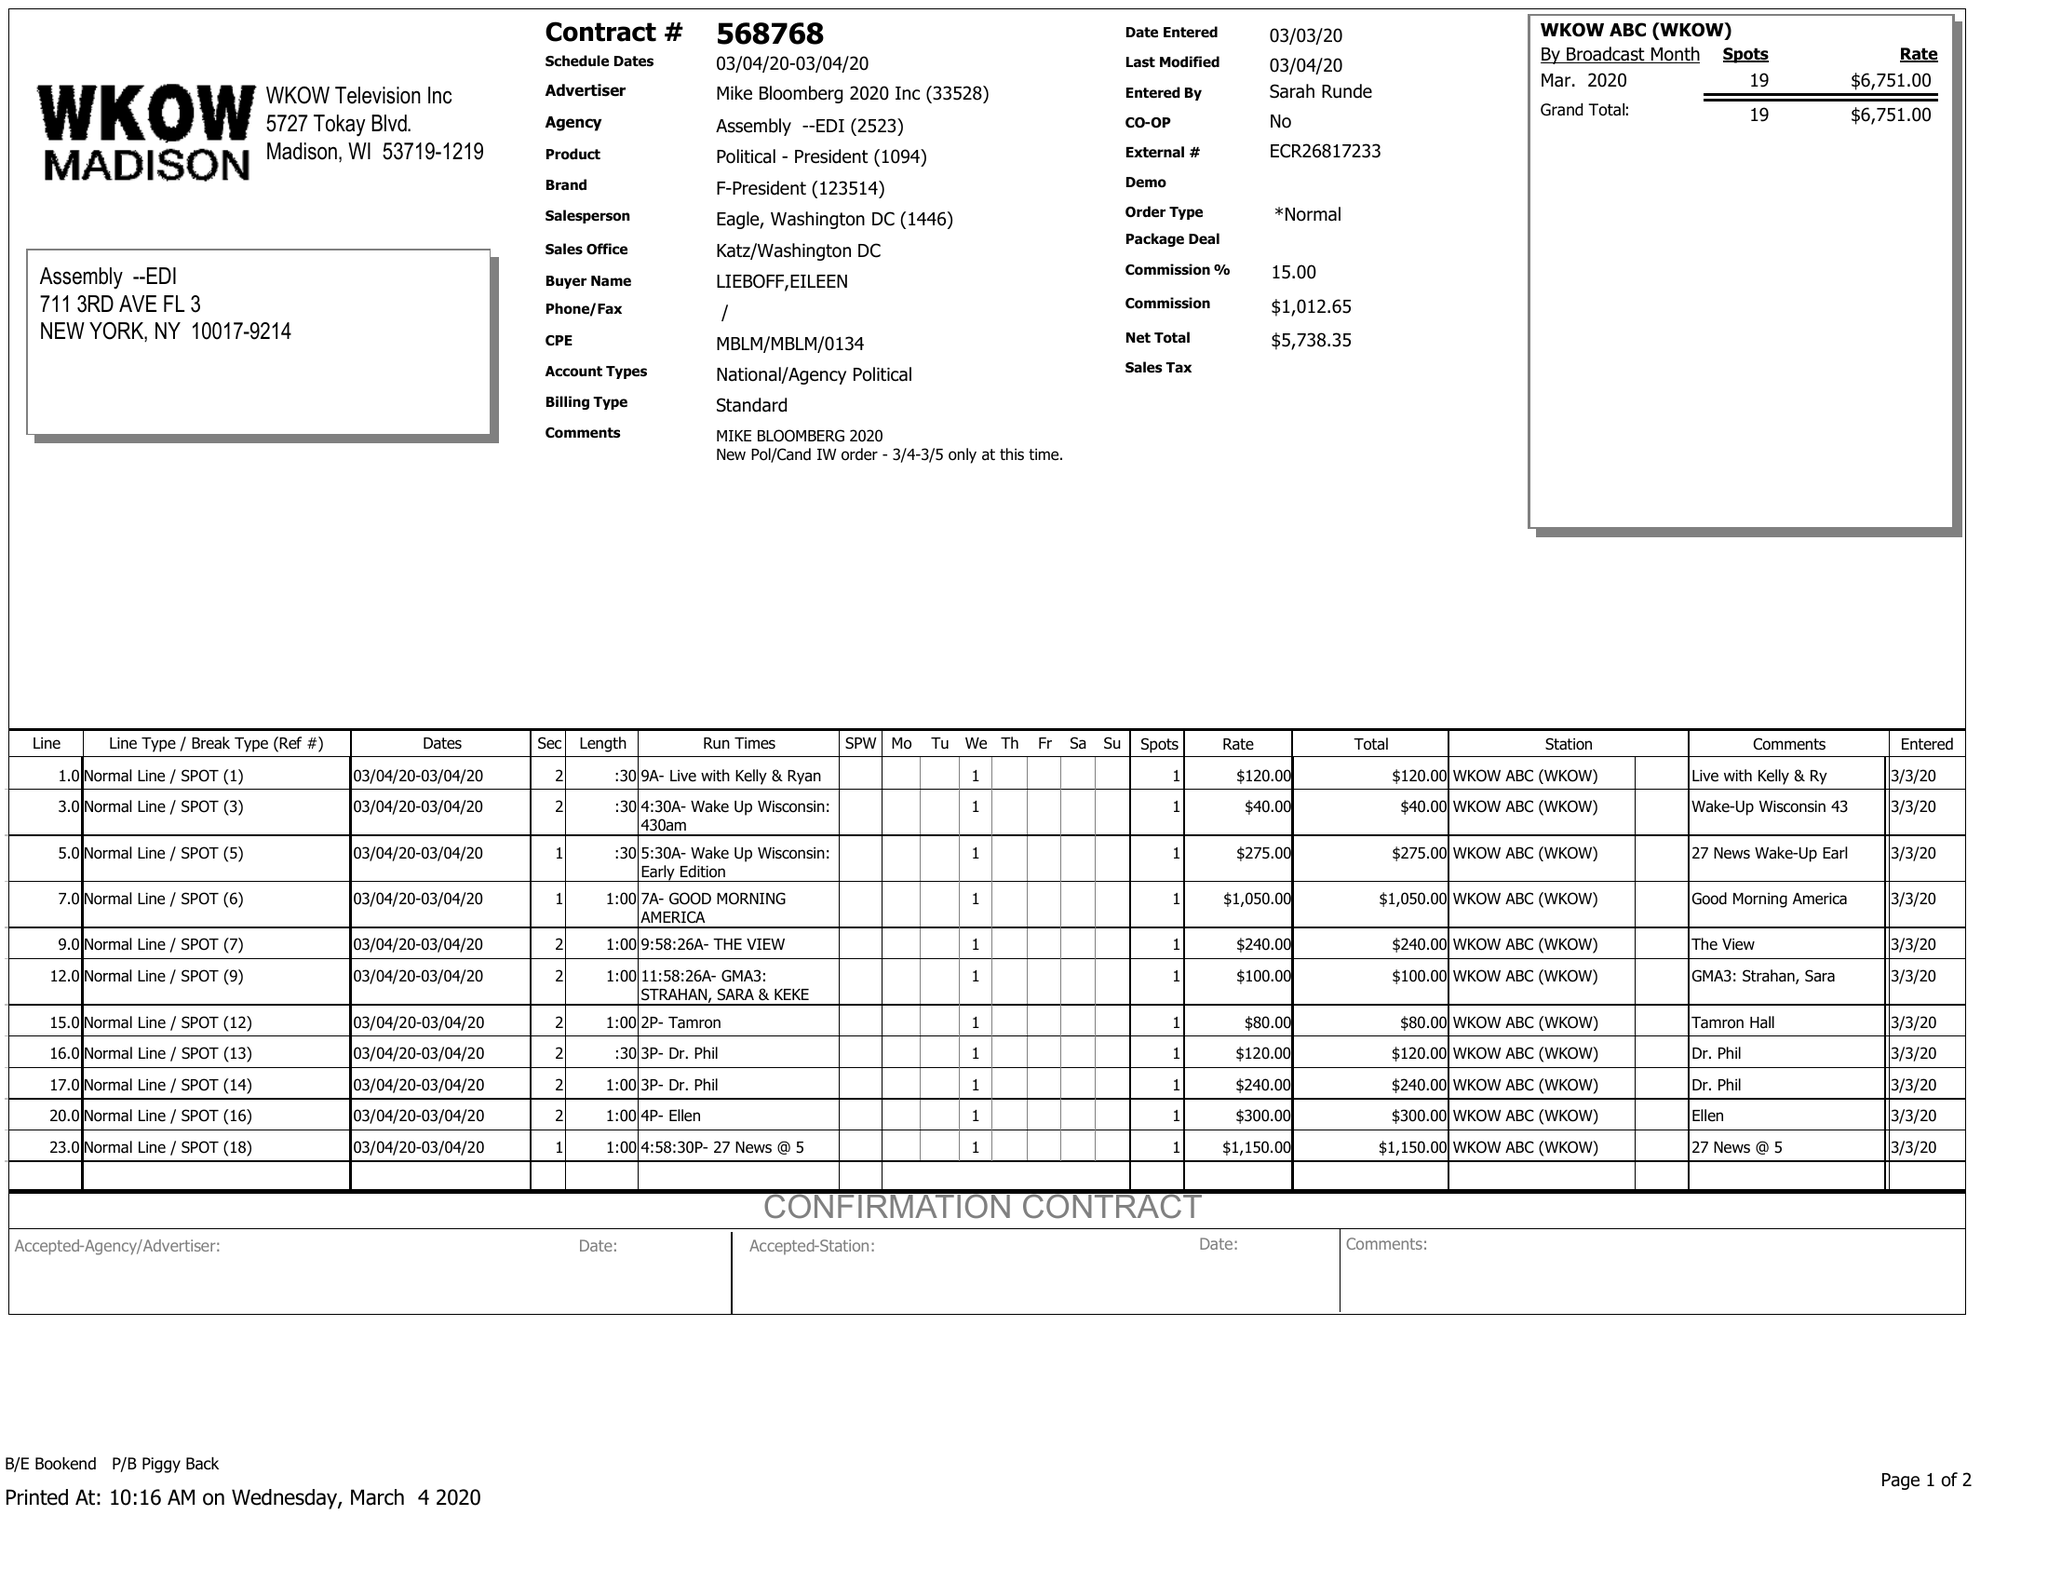What is the value for the advertiser?
Answer the question using a single word or phrase. MIKE BLOOMBERG 2020 INC 